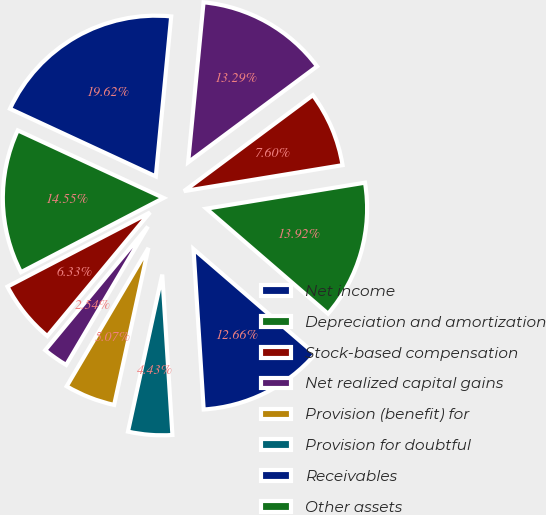<chart> <loc_0><loc_0><loc_500><loc_500><pie_chart><fcel>Net income<fcel>Depreciation and amortization<fcel>Stock-based compensation<fcel>Net realized capital gains<fcel>Provision (benefit) for<fcel>Provision for doubtful<fcel>Receivables<fcel>Other assets<fcel>Benefits payable<fcel>Other liabilities<nl><fcel>19.62%<fcel>14.55%<fcel>6.33%<fcel>2.54%<fcel>5.07%<fcel>4.43%<fcel>12.66%<fcel>13.92%<fcel>7.6%<fcel>13.29%<nl></chart> 